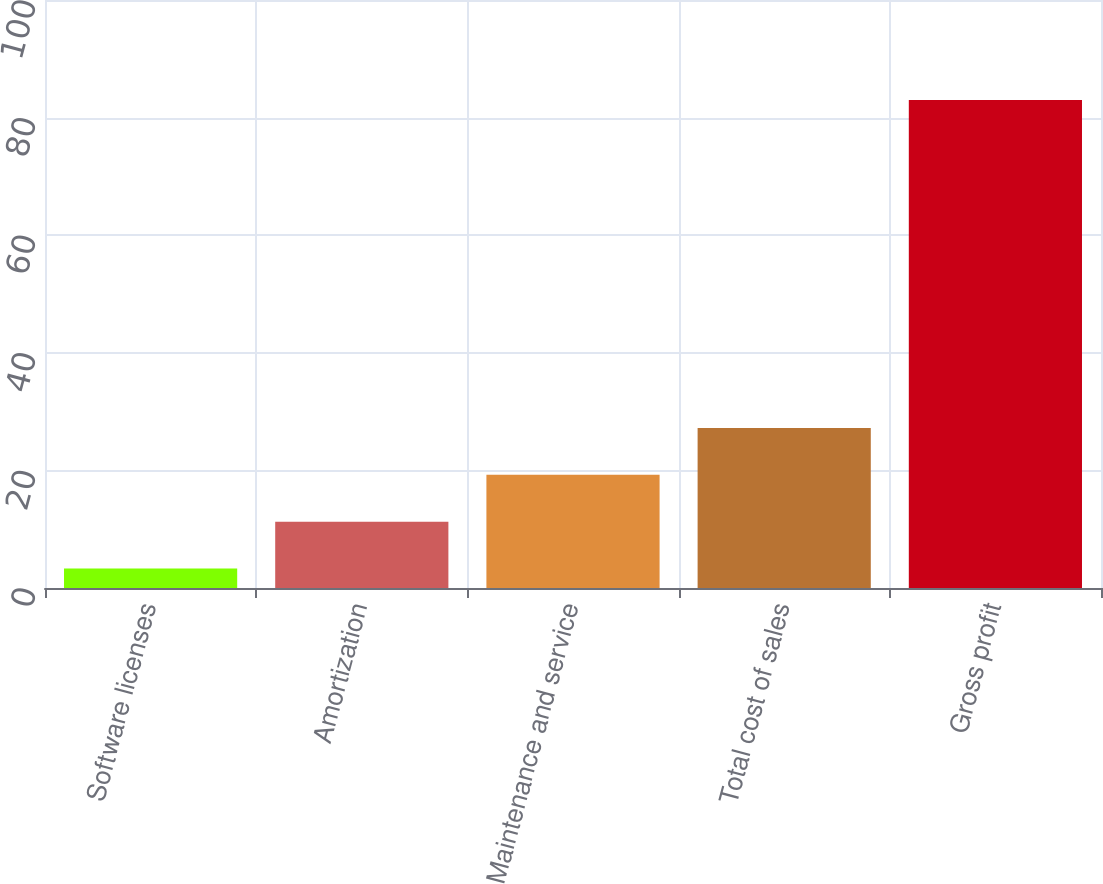Convert chart. <chart><loc_0><loc_0><loc_500><loc_500><bar_chart><fcel>Software licenses<fcel>Amortization<fcel>Maintenance and service<fcel>Total cost of sales<fcel>Gross profit<nl><fcel>3.3<fcel>11.27<fcel>19.24<fcel>27.21<fcel>83<nl></chart> 